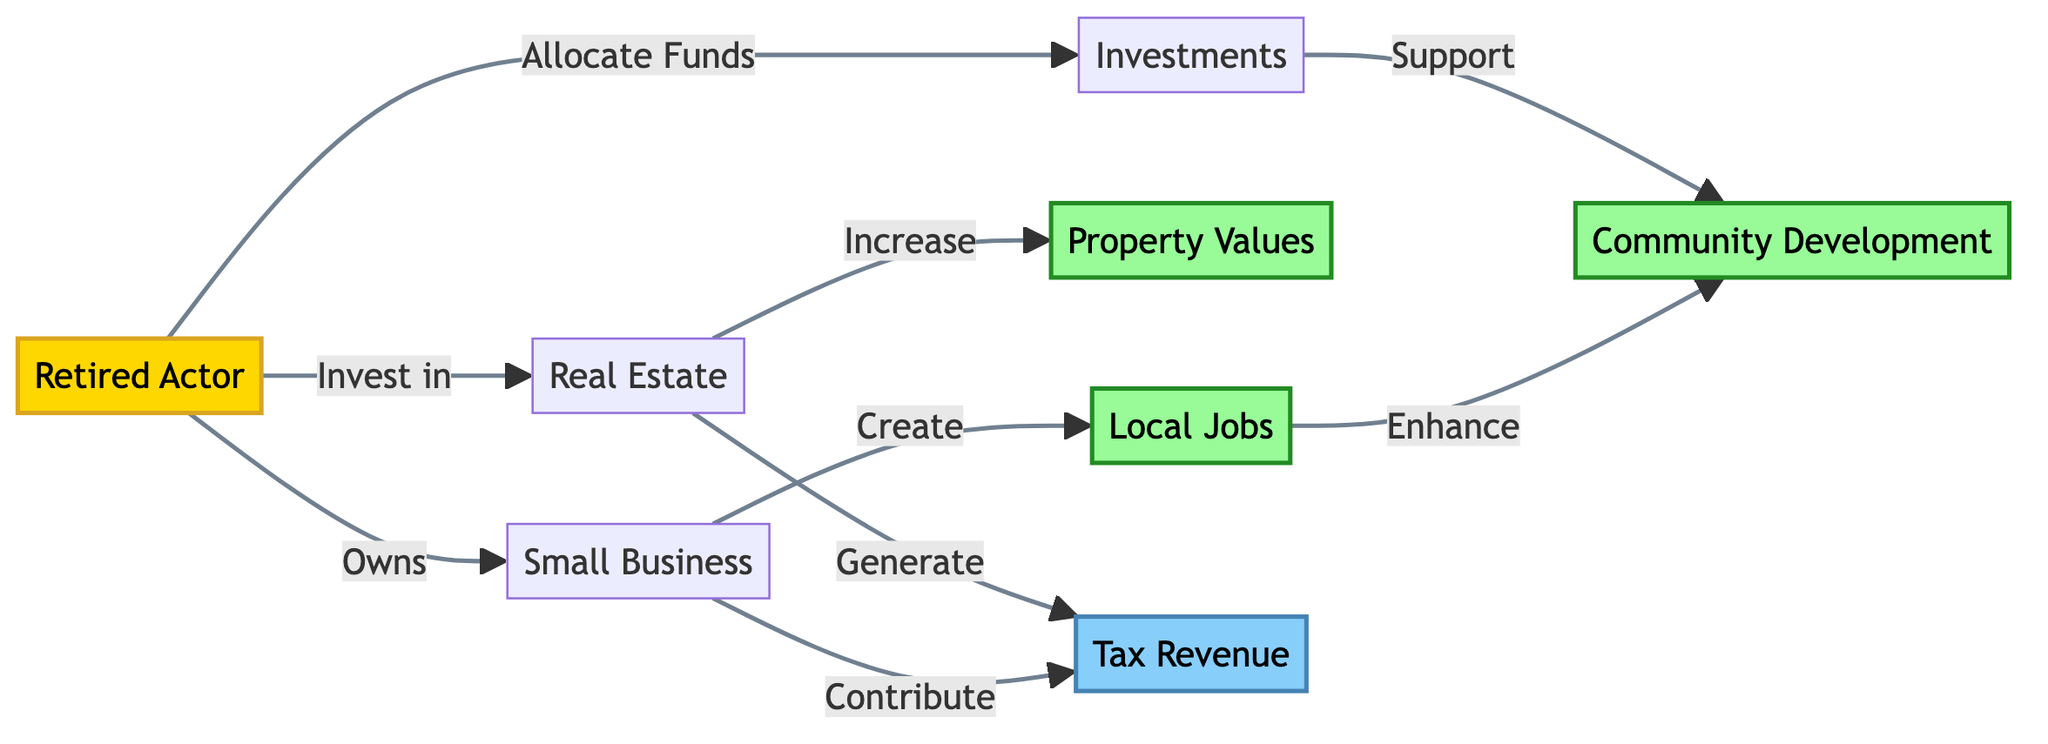What is the first node in the diagram? The first node listed in the diagram is "Retired Actor," which is labeled as node A.
Answer: Retired Actor How many types of impacts are indicated in the diagram? There are two impact types identified in the diagram: "Tax Revenue" and "Community Development." This can be verified by looking at nodes H and G.
Answer: 2 Which node represents job creation? The diagram specifies that "Small Business" is linked to the node representing "Local Jobs," indicating that small businesses contribute to job creation.
Answer: Small Business What does the arrow from "Retired Actor" to "Real Estate" signify? The arrow indicates a direct action or relationship where the "Retired Actor" invests in "Real Estate," showing the flow of investment towards real estate.
Answer: Invest in Which two outcomes are linked to "Small Business"? "Local Jobs" and "Tax Revenue" are both connected to "Small Business" in the diagram, as indicated by the arrows stemming from "Small Business."
Answer: Local Jobs, Tax Revenue What are the two connections from "Investments"? The "Investments" node connects to "Community Development" as a supporting action, and both contribute to "Tax Revenue." This requires tracing connections from the Investments node.
Answer: Support, Contribute How does "Real Estate" affect "Property Values"? The "Real Estate" node has a direct connection to "Property Values," indicating that there is an increase in property values as a result of investments in real estate.
Answer: Increase What is the relationship between "Job Creation" and "Community Development"? "Job Creation" enhances "Community Development" based on the flow from "Local Jobs" to "Community Development," implying that jobs contribute positively to community growth.
Answer: Enhance 